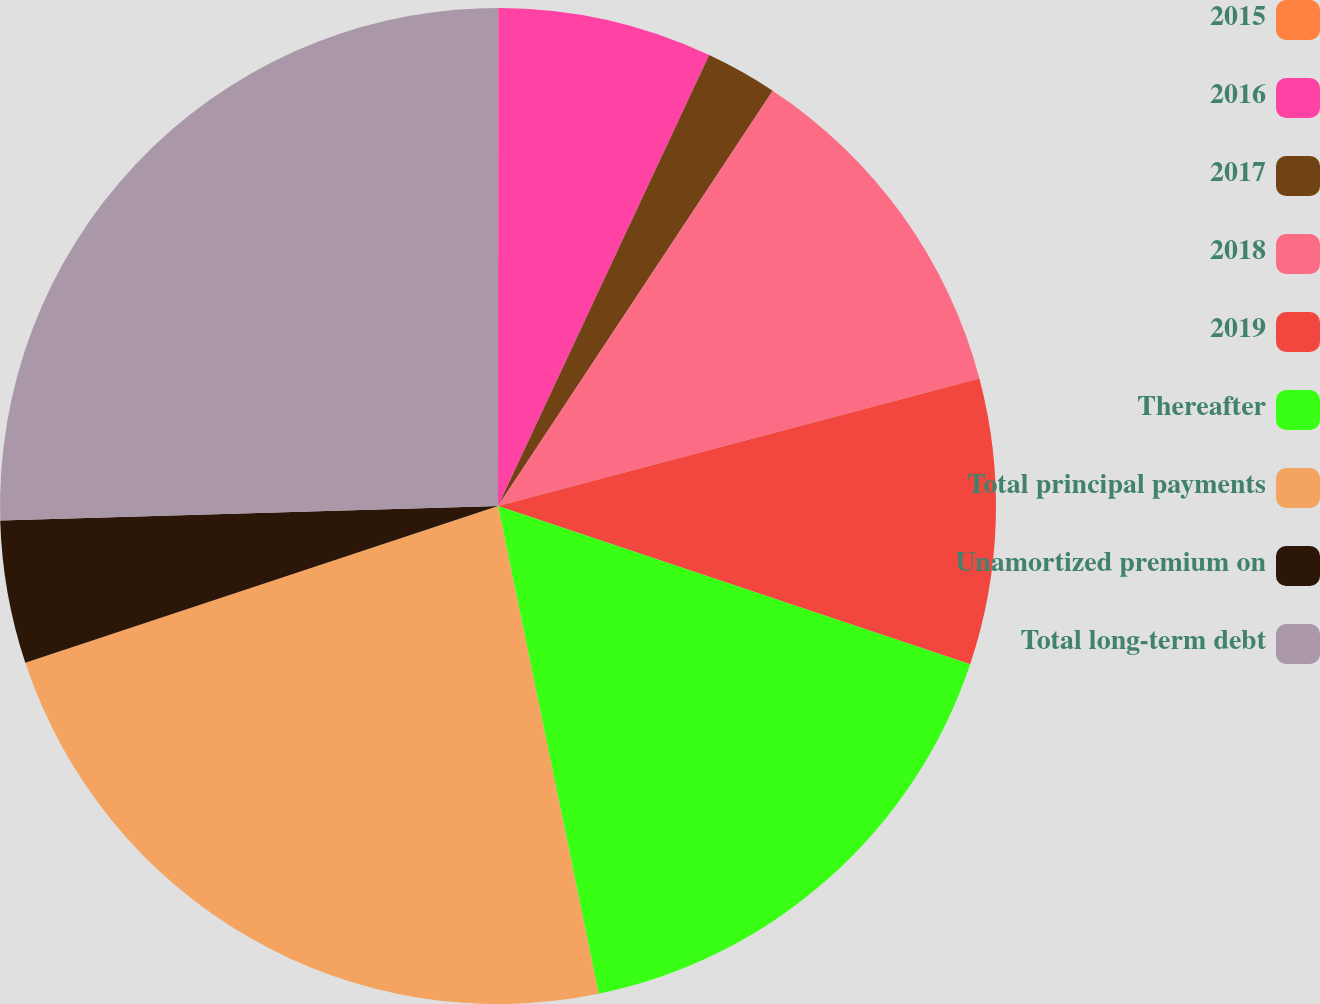Convert chart. <chart><loc_0><loc_0><loc_500><loc_500><pie_chart><fcel>2015<fcel>2016<fcel>2017<fcel>2018<fcel>2019<fcel>Thereafter<fcel>Total principal payments<fcel>Unamortized premium on<fcel>Total long-term debt<nl><fcel>0.01%<fcel>6.96%<fcel>2.33%<fcel>11.58%<fcel>9.27%<fcel>16.61%<fcel>23.14%<fcel>4.64%<fcel>25.46%<nl></chart> 